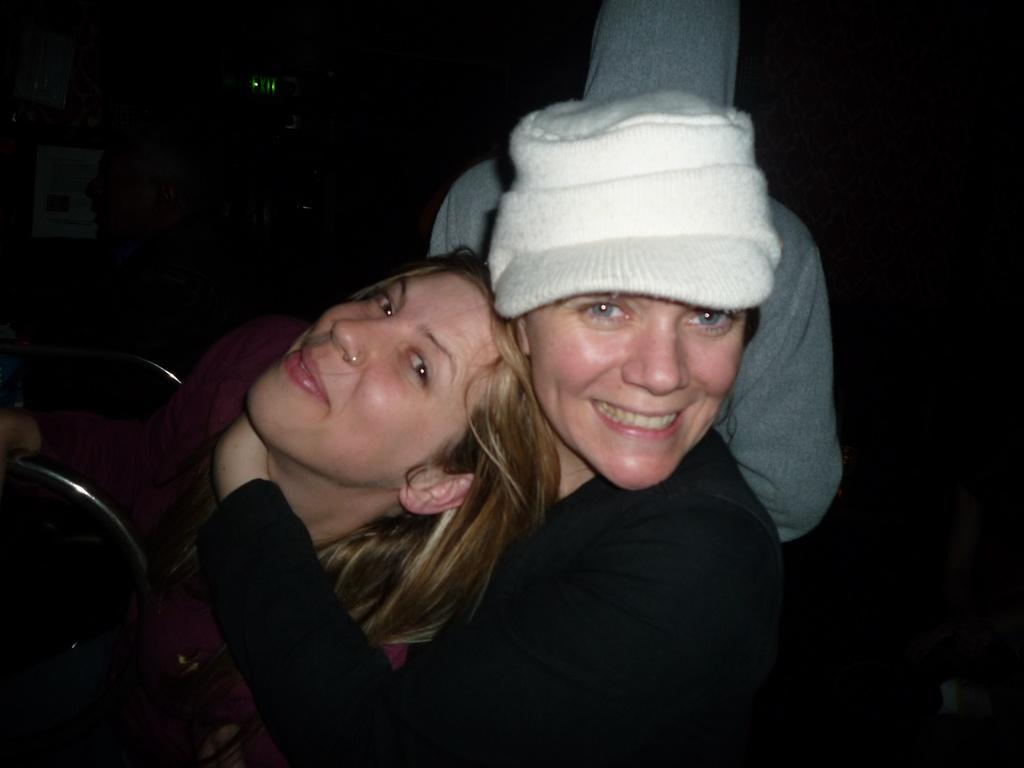How many women are in the image? There are two women in the image. What is one of the women wearing? One of the women is wearing a cap. What can be observed about the background of the image? The background of the image is dark. Can you describe the people in the background? There are two persons in the background. What type of furniture is present in the background? There are chairs in the background. What type of toy can be seen rolling on the floor in the image? There is no toy present in the image, and no rolling object can be observed. What color is the button on the woman's shirt in the image? There is no button mentioned or visible on the woman's shirt in the image. 